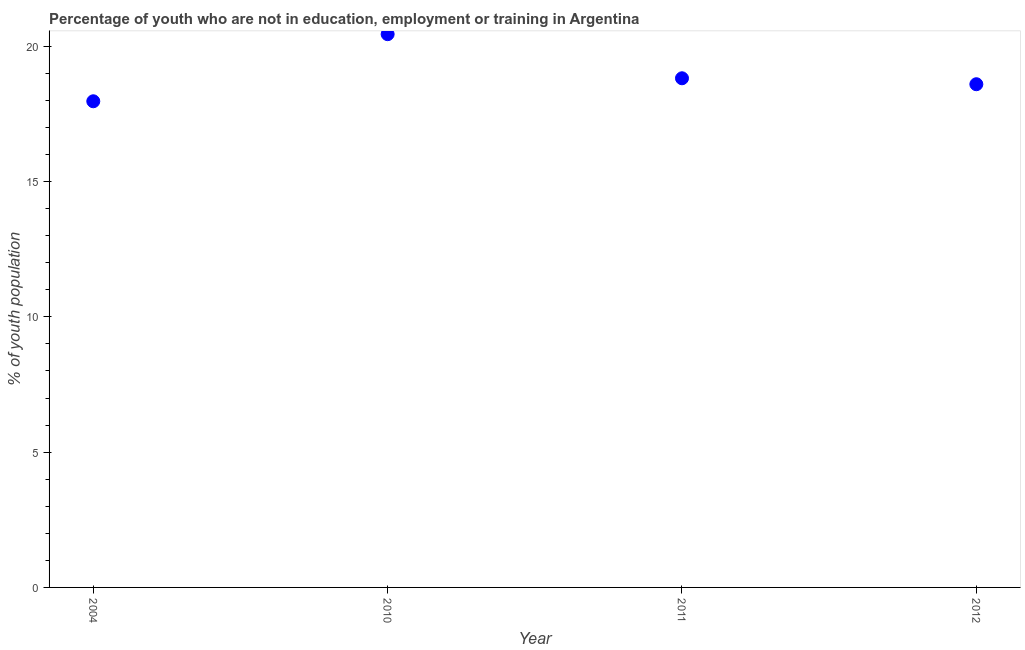What is the unemployed youth population in 2010?
Offer a very short reply. 20.45. Across all years, what is the maximum unemployed youth population?
Your answer should be compact. 20.45. Across all years, what is the minimum unemployed youth population?
Provide a succinct answer. 17.97. In which year was the unemployed youth population maximum?
Give a very brief answer. 2010. In which year was the unemployed youth population minimum?
Keep it short and to the point. 2004. What is the sum of the unemployed youth population?
Ensure brevity in your answer.  75.84. What is the difference between the unemployed youth population in 2004 and 2010?
Keep it short and to the point. -2.48. What is the average unemployed youth population per year?
Your response must be concise. 18.96. What is the median unemployed youth population?
Provide a short and direct response. 18.71. In how many years, is the unemployed youth population greater than 5 %?
Provide a succinct answer. 4. Do a majority of the years between 2004 and 2011 (inclusive) have unemployed youth population greater than 3 %?
Offer a terse response. Yes. What is the ratio of the unemployed youth population in 2010 to that in 2011?
Your response must be concise. 1.09. Is the unemployed youth population in 2004 less than that in 2010?
Make the answer very short. Yes. Is the difference between the unemployed youth population in 2004 and 2010 greater than the difference between any two years?
Provide a short and direct response. Yes. What is the difference between the highest and the second highest unemployed youth population?
Your response must be concise. 1.63. What is the difference between the highest and the lowest unemployed youth population?
Keep it short and to the point. 2.48. What is the difference between two consecutive major ticks on the Y-axis?
Offer a very short reply. 5. Are the values on the major ticks of Y-axis written in scientific E-notation?
Offer a very short reply. No. What is the title of the graph?
Your answer should be very brief. Percentage of youth who are not in education, employment or training in Argentina. What is the label or title of the X-axis?
Keep it short and to the point. Year. What is the label or title of the Y-axis?
Offer a terse response. % of youth population. What is the % of youth population in 2004?
Keep it short and to the point. 17.97. What is the % of youth population in 2010?
Provide a succinct answer. 20.45. What is the % of youth population in 2011?
Keep it short and to the point. 18.82. What is the % of youth population in 2012?
Give a very brief answer. 18.6. What is the difference between the % of youth population in 2004 and 2010?
Ensure brevity in your answer.  -2.48. What is the difference between the % of youth population in 2004 and 2011?
Ensure brevity in your answer.  -0.85. What is the difference between the % of youth population in 2004 and 2012?
Offer a terse response. -0.63. What is the difference between the % of youth population in 2010 and 2011?
Make the answer very short. 1.63. What is the difference between the % of youth population in 2010 and 2012?
Provide a short and direct response. 1.85. What is the difference between the % of youth population in 2011 and 2012?
Offer a terse response. 0.22. What is the ratio of the % of youth population in 2004 to that in 2010?
Your answer should be compact. 0.88. What is the ratio of the % of youth population in 2004 to that in 2011?
Make the answer very short. 0.95. What is the ratio of the % of youth population in 2010 to that in 2011?
Keep it short and to the point. 1.09. What is the ratio of the % of youth population in 2010 to that in 2012?
Keep it short and to the point. 1.1. What is the ratio of the % of youth population in 2011 to that in 2012?
Your response must be concise. 1.01. 